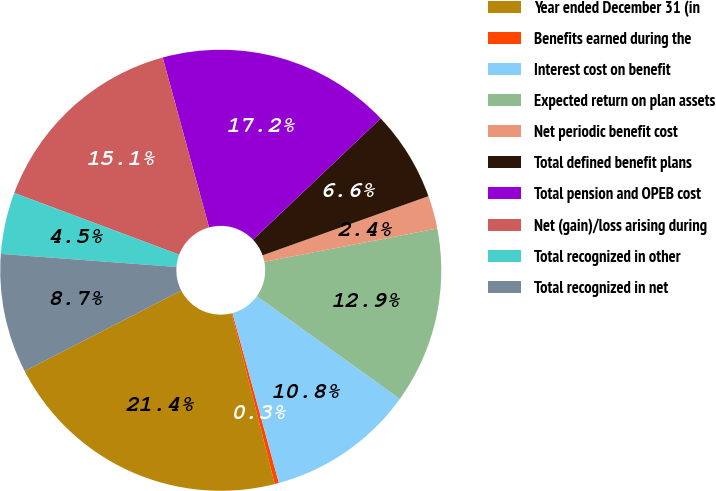Convert chart to OTSL. <chart><loc_0><loc_0><loc_500><loc_500><pie_chart><fcel>Year ended December 31 (in<fcel>Benefits earned during the<fcel>Interest cost on benefit<fcel>Expected return on plan assets<fcel>Net periodic benefit cost<fcel>Total defined benefit plans<fcel>Total pension and OPEB cost<fcel>Net (gain)/loss arising during<fcel>Total recognized in other<fcel>Total recognized in net<nl><fcel>21.38%<fcel>0.31%<fcel>10.84%<fcel>12.95%<fcel>2.42%<fcel>6.63%<fcel>17.16%<fcel>15.06%<fcel>4.52%<fcel>8.74%<nl></chart> 